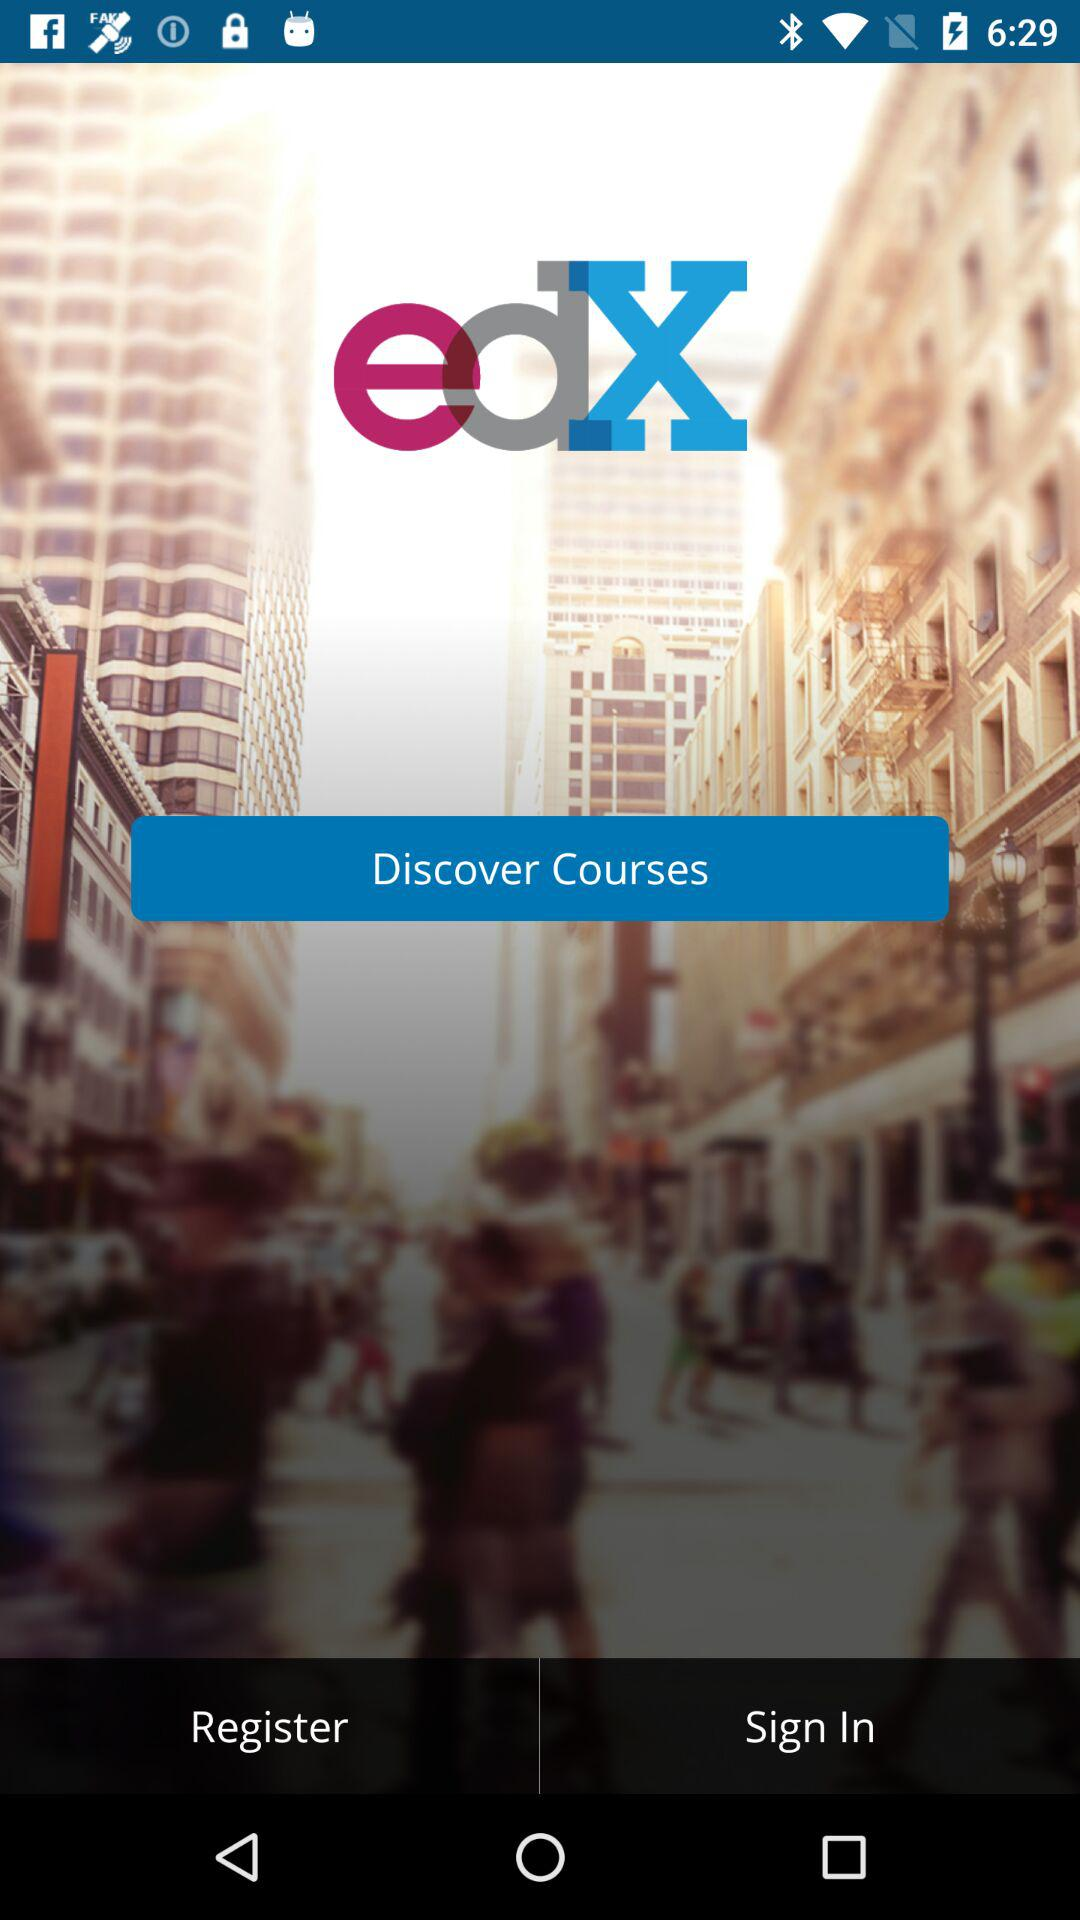What is the name of the application? The name of the application is "edX". 